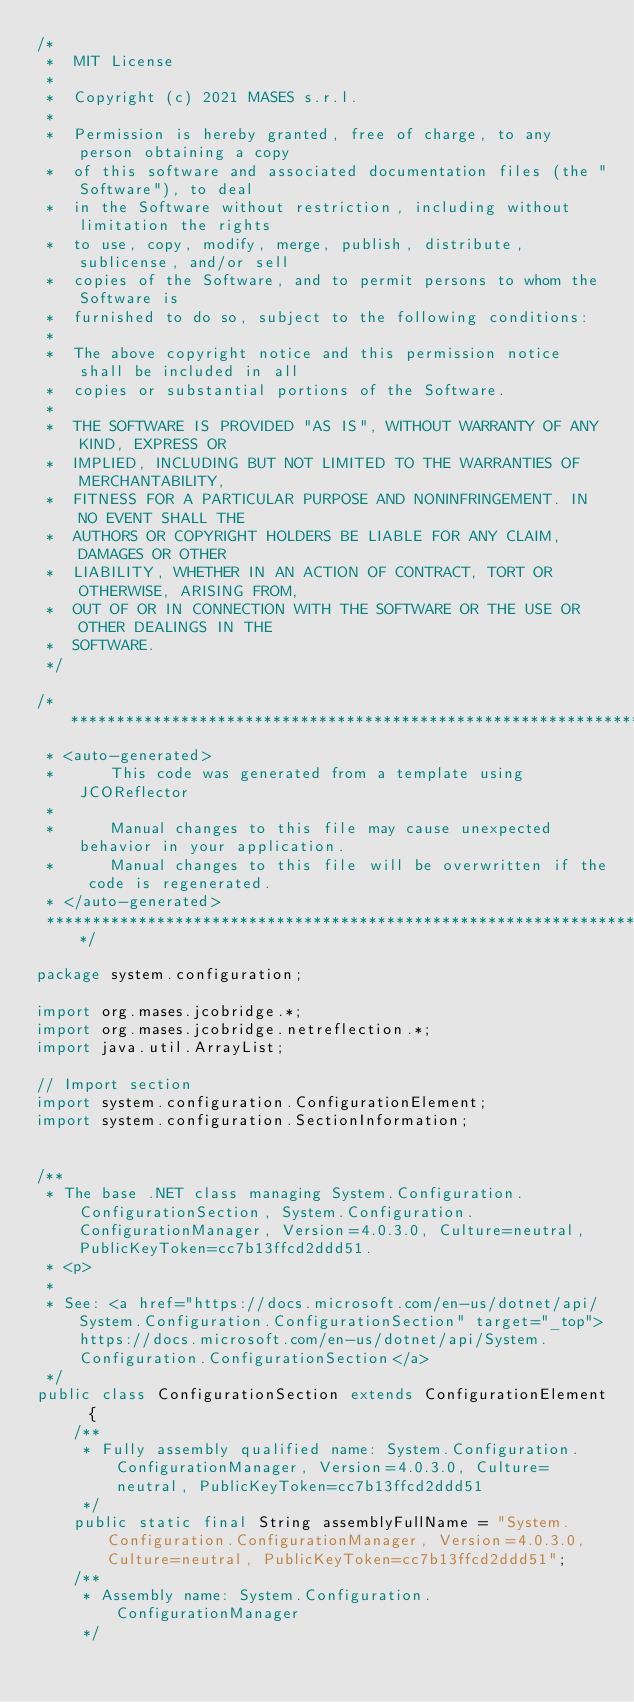<code> <loc_0><loc_0><loc_500><loc_500><_Java_>/*
 *  MIT License
 *
 *  Copyright (c) 2021 MASES s.r.l.
 *
 *  Permission is hereby granted, free of charge, to any person obtaining a copy
 *  of this software and associated documentation files (the "Software"), to deal
 *  in the Software without restriction, including without limitation the rights
 *  to use, copy, modify, merge, publish, distribute, sublicense, and/or sell
 *  copies of the Software, and to permit persons to whom the Software is
 *  furnished to do so, subject to the following conditions:
 *
 *  The above copyright notice and this permission notice shall be included in all
 *  copies or substantial portions of the Software.
 *
 *  THE SOFTWARE IS PROVIDED "AS IS", WITHOUT WARRANTY OF ANY KIND, EXPRESS OR
 *  IMPLIED, INCLUDING BUT NOT LIMITED TO THE WARRANTIES OF MERCHANTABILITY,
 *  FITNESS FOR A PARTICULAR PURPOSE AND NONINFRINGEMENT. IN NO EVENT SHALL THE
 *  AUTHORS OR COPYRIGHT HOLDERS BE LIABLE FOR ANY CLAIM, DAMAGES OR OTHER
 *  LIABILITY, WHETHER IN AN ACTION OF CONTRACT, TORT OR OTHERWISE, ARISING FROM,
 *  OUT OF OR IN CONNECTION WITH THE SOFTWARE OR THE USE OR OTHER DEALINGS IN THE
 *  SOFTWARE.
 */

/**************************************************************************************
 * <auto-generated>
 *      This code was generated from a template using JCOReflector
 * 
 *      Manual changes to this file may cause unexpected behavior in your application.
 *      Manual changes to this file will be overwritten if the code is regenerated.
 * </auto-generated>
 *************************************************************************************/

package system.configuration;

import org.mases.jcobridge.*;
import org.mases.jcobridge.netreflection.*;
import java.util.ArrayList;

// Import section
import system.configuration.ConfigurationElement;
import system.configuration.SectionInformation;


/**
 * The base .NET class managing System.Configuration.ConfigurationSection, System.Configuration.ConfigurationManager, Version=4.0.3.0, Culture=neutral, PublicKeyToken=cc7b13ffcd2ddd51.
 * <p>
 * 
 * See: <a href="https://docs.microsoft.com/en-us/dotnet/api/System.Configuration.ConfigurationSection" target="_top">https://docs.microsoft.com/en-us/dotnet/api/System.Configuration.ConfigurationSection</a>
 */
public class ConfigurationSection extends ConfigurationElement  {
    /**
     * Fully assembly qualified name: System.Configuration.ConfigurationManager, Version=4.0.3.0, Culture=neutral, PublicKeyToken=cc7b13ffcd2ddd51
     */
    public static final String assemblyFullName = "System.Configuration.ConfigurationManager, Version=4.0.3.0, Culture=neutral, PublicKeyToken=cc7b13ffcd2ddd51";
    /**
     * Assembly name: System.Configuration.ConfigurationManager
     */</code> 